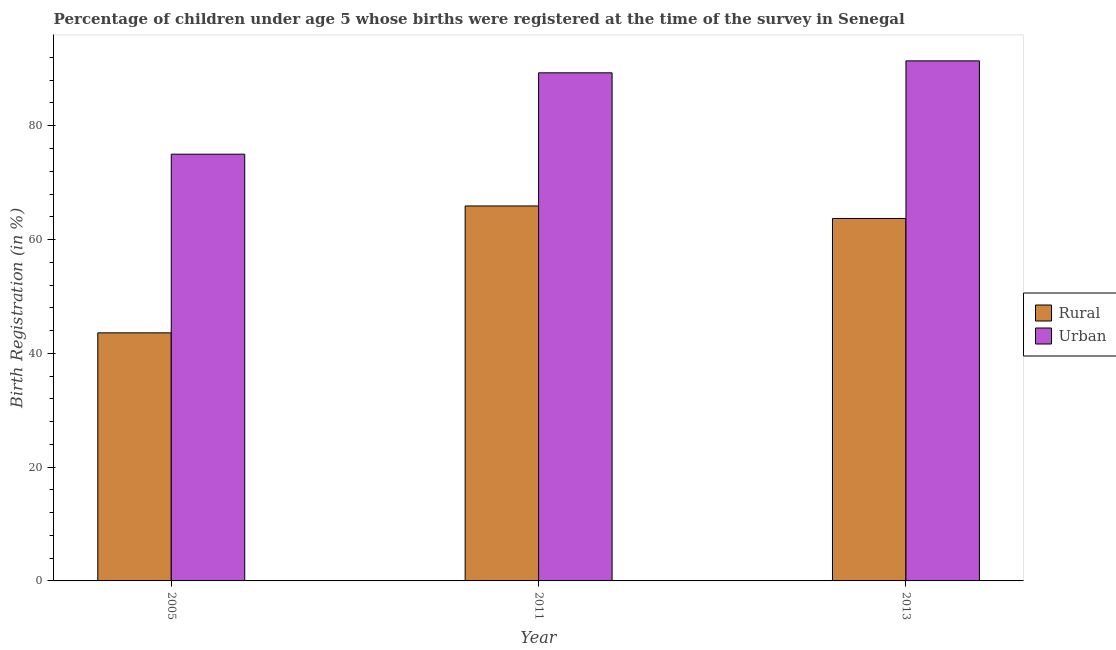How many different coloured bars are there?
Your answer should be compact. 2. Are the number of bars per tick equal to the number of legend labels?
Offer a very short reply. Yes. How many bars are there on the 2nd tick from the right?
Ensure brevity in your answer.  2. What is the label of the 2nd group of bars from the left?
Provide a short and direct response. 2011. Across all years, what is the maximum urban birth registration?
Provide a succinct answer. 91.4. Across all years, what is the minimum rural birth registration?
Provide a succinct answer. 43.6. In which year was the rural birth registration minimum?
Your answer should be compact. 2005. What is the total rural birth registration in the graph?
Your response must be concise. 173.2. What is the difference between the urban birth registration in 2005 and that in 2011?
Offer a terse response. -14.3. What is the difference between the urban birth registration in 2005 and the rural birth registration in 2011?
Give a very brief answer. -14.3. What is the average urban birth registration per year?
Your answer should be very brief. 85.23. What is the ratio of the rural birth registration in 2005 to that in 2013?
Make the answer very short. 0.68. What is the difference between the highest and the second highest rural birth registration?
Provide a short and direct response. 2.2. What is the difference between the highest and the lowest urban birth registration?
Offer a very short reply. 16.4. In how many years, is the urban birth registration greater than the average urban birth registration taken over all years?
Keep it short and to the point. 2. What does the 1st bar from the left in 2005 represents?
Provide a succinct answer. Rural. What does the 2nd bar from the right in 2013 represents?
Your response must be concise. Rural. How many bars are there?
Offer a terse response. 6. Are all the bars in the graph horizontal?
Provide a short and direct response. No. How many years are there in the graph?
Your response must be concise. 3. What is the difference between two consecutive major ticks on the Y-axis?
Make the answer very short. 20. Are the values on the major ticks of Y-axis written in scientific E-notation?
Ensure brevity in your answer.  No. Does the graph contain any zero values?
Keep it short and to the point. No. Where does the legend appear in the graph?
Your answer should be compact. Center right. How are the legend labels stacked?
Your answer should be compact. Vertical. What is the title of the graph?
Provide a short and direct response. Percentage of children under age 5 whose births were registered at the time of the survey in Senegal. Does "Secondary school" appear as one of the legend labels in the graph?
Offer a terse response. No. What is the label or title of the X-axis?
Your response must be concise. Year. What is the label or title of the Y-axis?
Offer a very short reply. Birth Registration (in %). What is the Birth Registration (in %) in Rural in 2005?
Your answer should be compact. 43.6. What is the Birth Registration (in %) of Rural in 2011?
Keep it short and to the point. 65.9. What is the Birth Registration (in %) of Urban in 2011?
Provide a short and direct response. 89.3. What is the Birth Registration (in %) in Rural in 2013?
Keep it short and to the point. 63.7. What is the Birth Registration (in %) of Urban in 2013?
Provide a short and direct response. 91.4. Across all years, what is the maximum Birth Registration (in %) in Rural?
Your answer should be compact. 65.9. Across all years, what is the maximum Birth Registration (in %) of Urban?
Your answer should be compact. 91.4. Across all years, what is the minimum Birth Registration (in %) of Rural?
Keep it short and to the point. 43.6. Across all years, what is the minimum Birth Registration (in %) of Urban?
Provide a short and direct response. 75. What is the total Birth Registration (in %) of Rural in the graph?
Keep it short and to the point. 173.2. What is the total Birth Registration (in %) in Urban in the graph?
Offer a terse response. 255.7. What is the difference between the Birth Registration (in %) in Rural in 2005 and that in 2011?
Give a very brief answer. -22.3. What is the difference between the Birth Registration (in %) of Urban in 2005 and that in 2011?
Offer a very short reply. -14.3. What is the difference between the Birth Registration (in %) in Rural in 2005 and that in 2013?
Provide a succinct answer. -20.1. What is the difference between the Birth Registration (in %) in Urban in 2005 and that in 2013?
Make the answer very short. -16.4. What is the difference between the Birth Registration (in %) in Urban in 2011 and that in 2013?
Make the answer very short. -2.1. What is the difference between the Birth Registration (in %) of Rural in 2005 and the Birth Registration (in %) of Urban in 2011?
Provide a short and direct response. -45.7. What is the difference between the Birth Registration (in %) of Rural in 2005 and the Birth Registration (in %) of Urban in 2013?
Keep it short and to the point. -47.8. What is the difference between the Birth Registration (in %) in Rural in 2011 and the Birth Registration (in %) in Urban in 2013?
Keep it short and to the point. -25.5. What is the average Birth Registration (in %) in Rural per year?
Your answer should be compact. 57.73. What is the average Birth Registration (in %) in Urban per year?
Your response must be concise. 85.23. In the year 2005, what is the difference between the Birth Registration (in %) in Rural and Birth Registration (in %) in Urban?
Your answer should be very brief. -31.4. In the year 2011, what is the difference between the Birth Registration (in %) in Rural and Birth Registration (in %) in Urban?
Keep it short and to the point. -23.4. In the year 2013, what is the difference between the Birth Registration (in %) of Rural and Birth Registration (in %) of Urban?
Your answer should be very brief. -27.7. What is the ratio of the Birth Registration (in %) of Rural in 2005 to that in 2011?
Ensure brevity in your answer.  0.66. What is the ratio of the Birth Registration (in %) in Urban in 2005 to that in 2011?
Provide a short and direct response. 0.84. What is the ratio of the Birth Registration (in %) in Rural in 2005 to that in 2013?
Offer a terse response. 0.68. What is the ratio of the Birth Registration (in %) in Urban in 2005 to that in 2013?
Offer a very short reply. 0.82. What is the ratio of the Birth Registration (in %) of Rural in 2011 to that in 2013?
Offer a very short reply. 1.03. What is the difference between the highest and the second highest Birth Registration (in %) in Rural?
Make the answer very short. 2.2. What is the difference between the highest and the lowest Birth Registration (in %) of Rural?
Your answer should be compact. 22.3. 